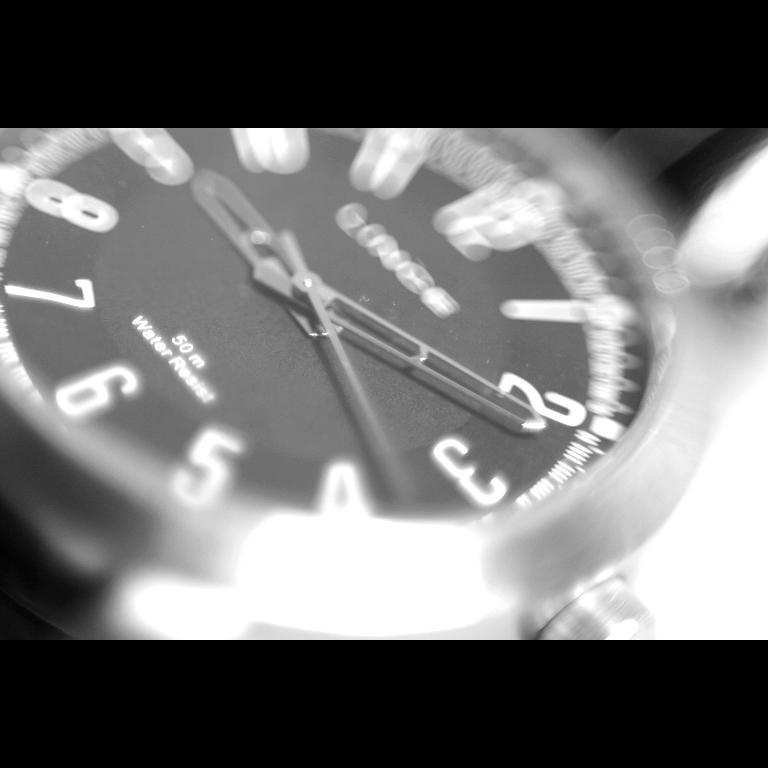<image>
Summarize the visual content of the image. A watch with a black face and white numbers, water resistant and can withstand up to 50m depth in water. 